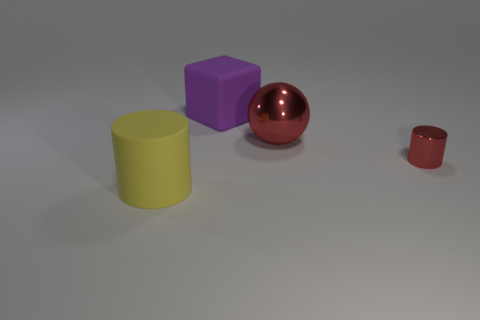How big is the red metal object in front of the red object that is behind the tiny cylinder that is in front of the purple block?
Provide a succinct answer. Small. How many other objects are the same shape as the tiny red thing?
Keep it short and to the point. 1. Does the shiny thing on the left side of the red cylinder have the same color as the cylinder behind the big yellow object?
Make the answer very short. Yes. What color is the cube that is the same size as the ball?
Offer a very short reply. Purple. Are there any spheres of the same color as the small shiny thing?
Your response must be concise. Yes. There is a cylinder to the right of the cube; is it the same size as the cube?
Provide a short and direct response. No. Are there the same number of purple cubes behind the big matte cube and big cyan cylinders?
Make the answer very short. Yes. How many things are either big things right of the big yellow cylinder or big yellow cylinders?
Keep it short and to the point. 3. The big thing that is both on the right side of the big cylinder and in front of the big purple cube has what shape?
Make the answer very short. Sphere. How many objects are either metallic objects that are in front of the red sphere or big things behind the yellow rubber thing?
Make the answer very short. 3. 